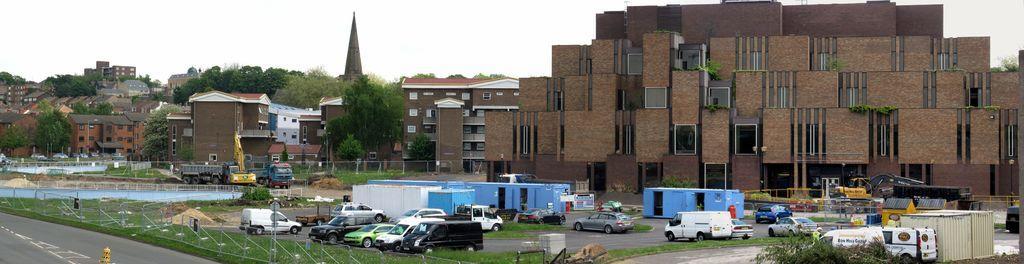Could you give a brief overview of what you see in this image? In the foreground of the picture we can see vehicles, grass, plants, fencing, road, containers and various objects. In the middle of the picture there are buildings, trees and a steeple. At the top it is sky. 